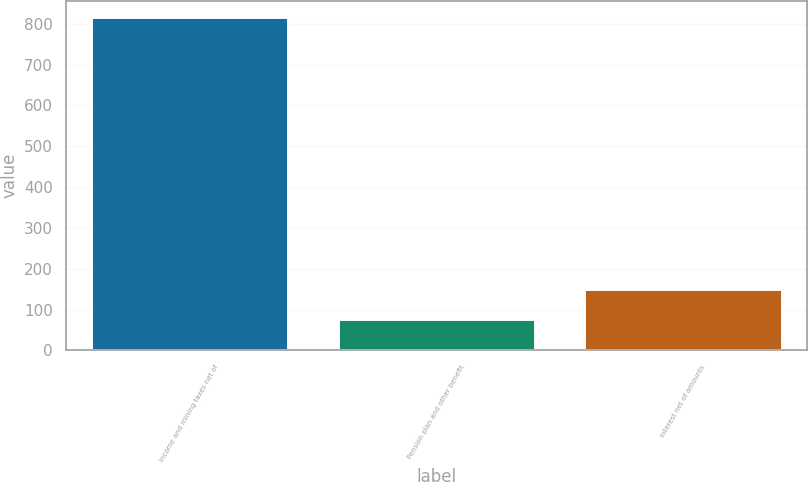<chart> <loc_0><loc_0><loc_500><loc_500><bar_chart><fcel>Income and mining taxes net of<fcel>Pension plan and other benefit<fcel>Interest net of amounts<nl><fcel>816<fcel>76<fcel>150<nl></chart> 